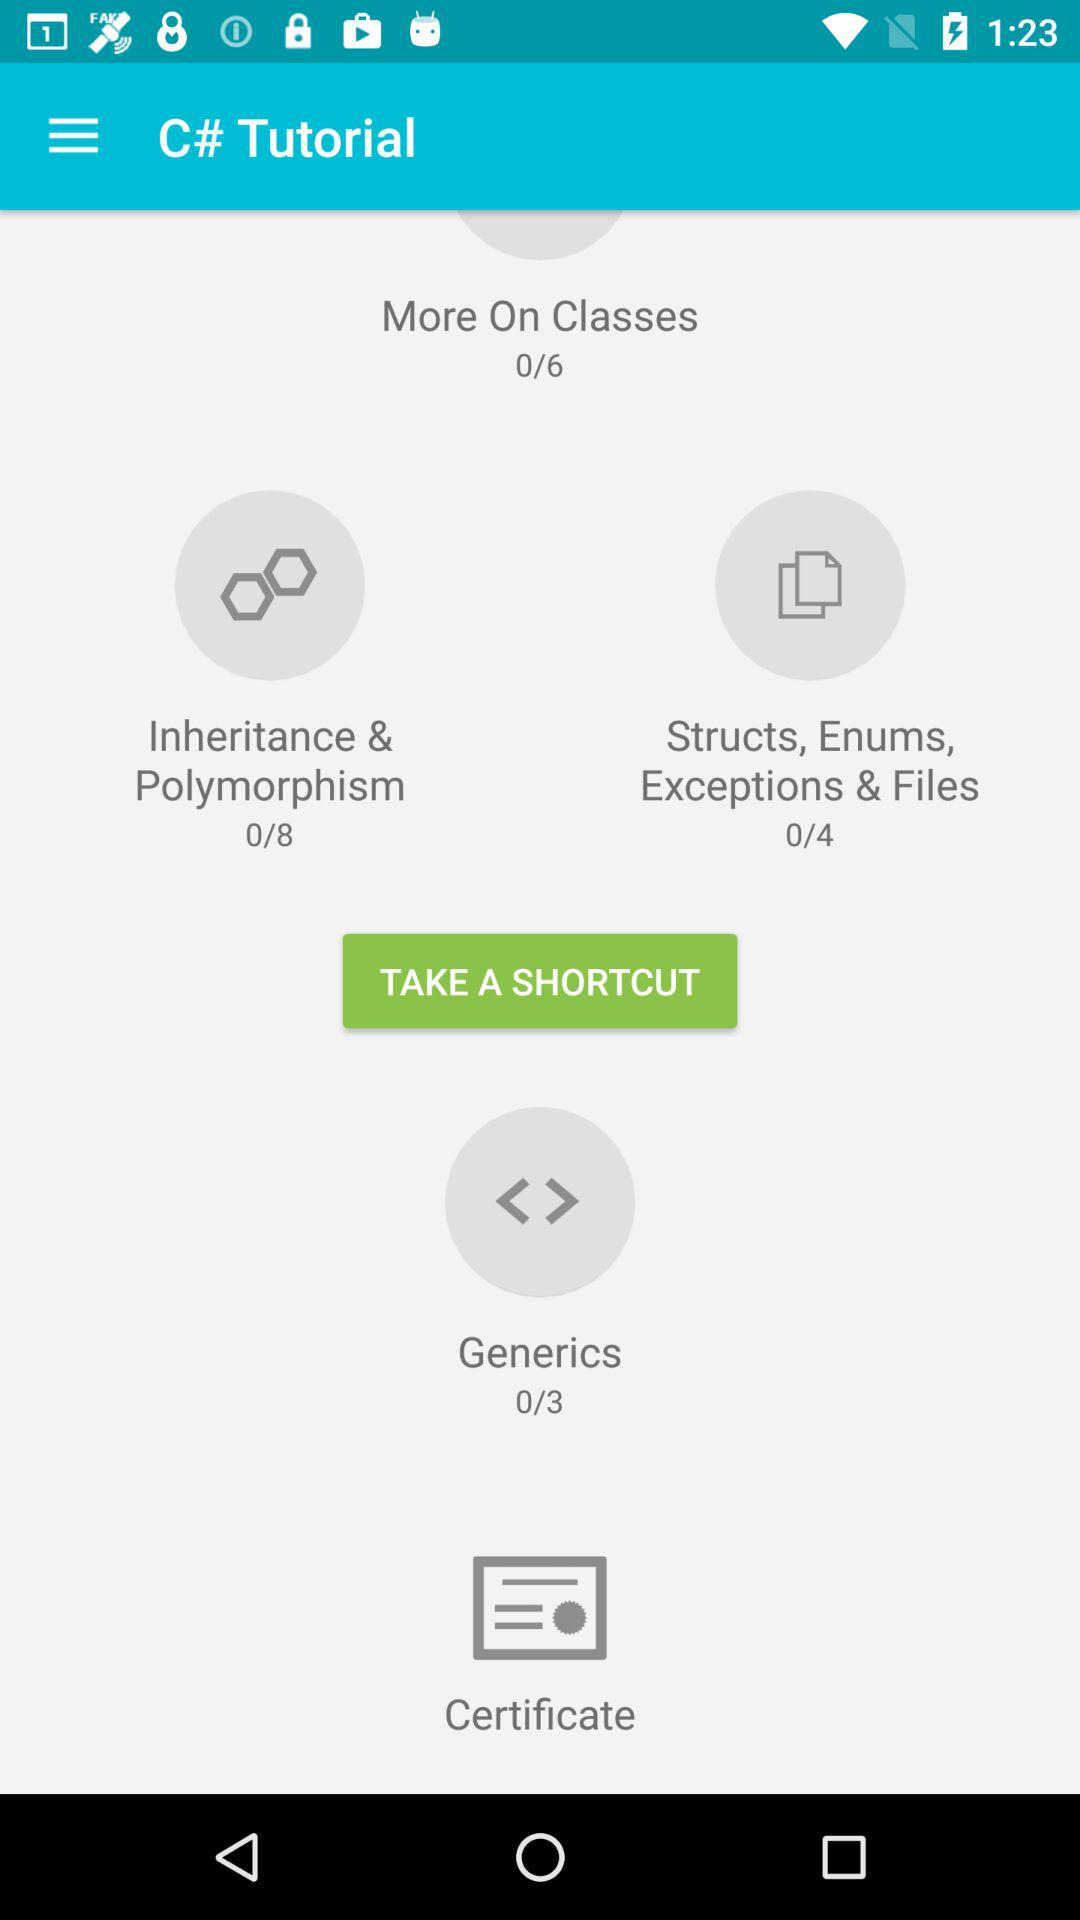How many chapters are there in "Inheritance & Polymorphism"? There are 8 chapters in "Inheritance & Polymorphism". 